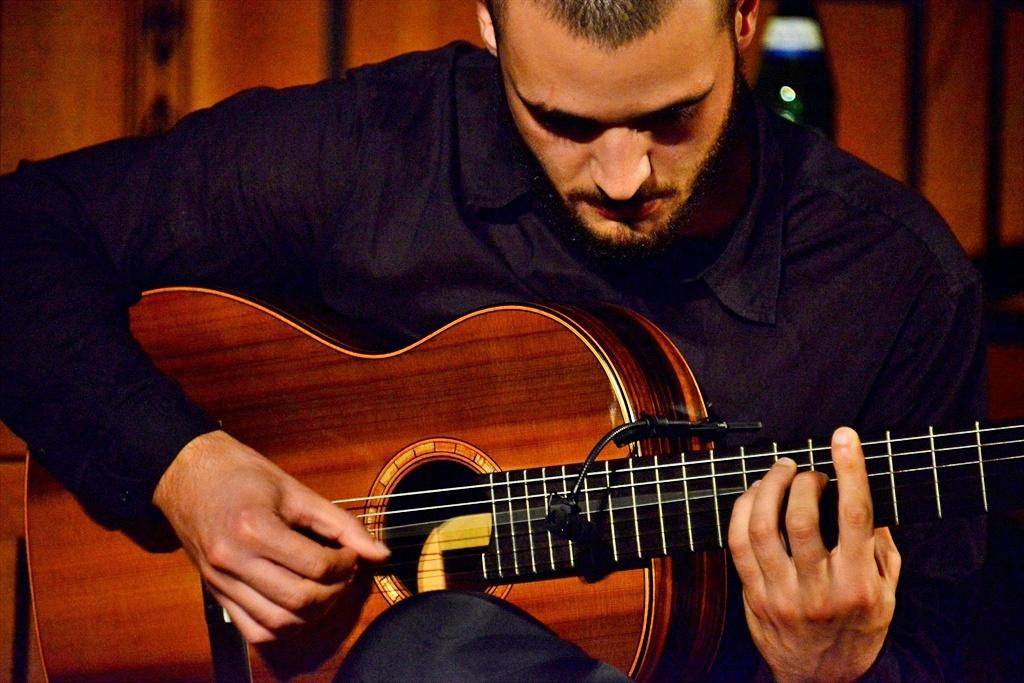What is the man in the image doing? The man is playing a guitar. How is the man holding the guitar? The man is holding the guitar in his hands. What type of horse can be seen in the image? There is no horse present in the image; it features a man playing a guitar. 